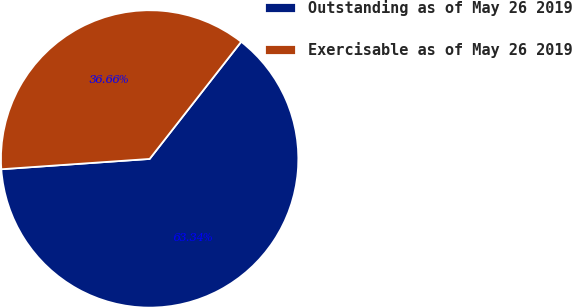<chart> <loc_0><loc_0><loc_500><loc_500><pie_chart><fcel>Outstanding as of May 26 2019<fcel>Exercisable as of May 26 2019<nl><fcel>63.34%<fcel>36.66%<nl></chart> 